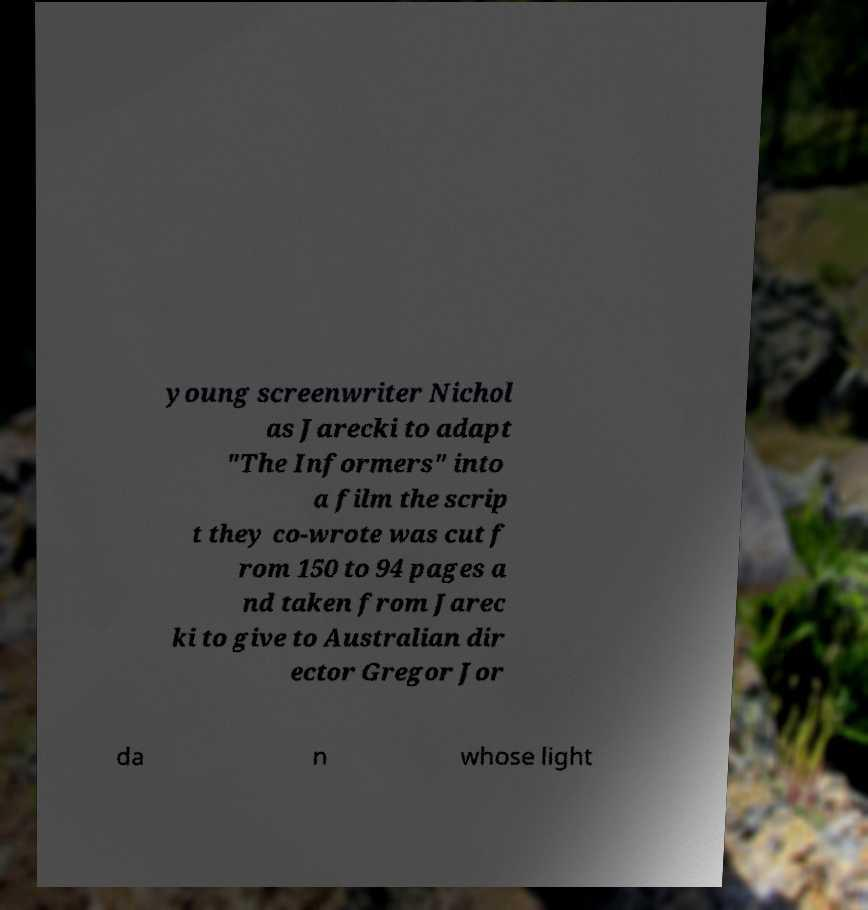Can you read and provide the text displayed in the image?This photo seems to have some interesting text. Can you extract and type it out for me? young screenwriter Nichol as Jarecki to adapt "The Informers" into a film the scrip t they co-wrote was cut f rom 150 to 94 pages a nd taken from Jarec ki to give to Australian dir ector Gregor Jor da n whose light 